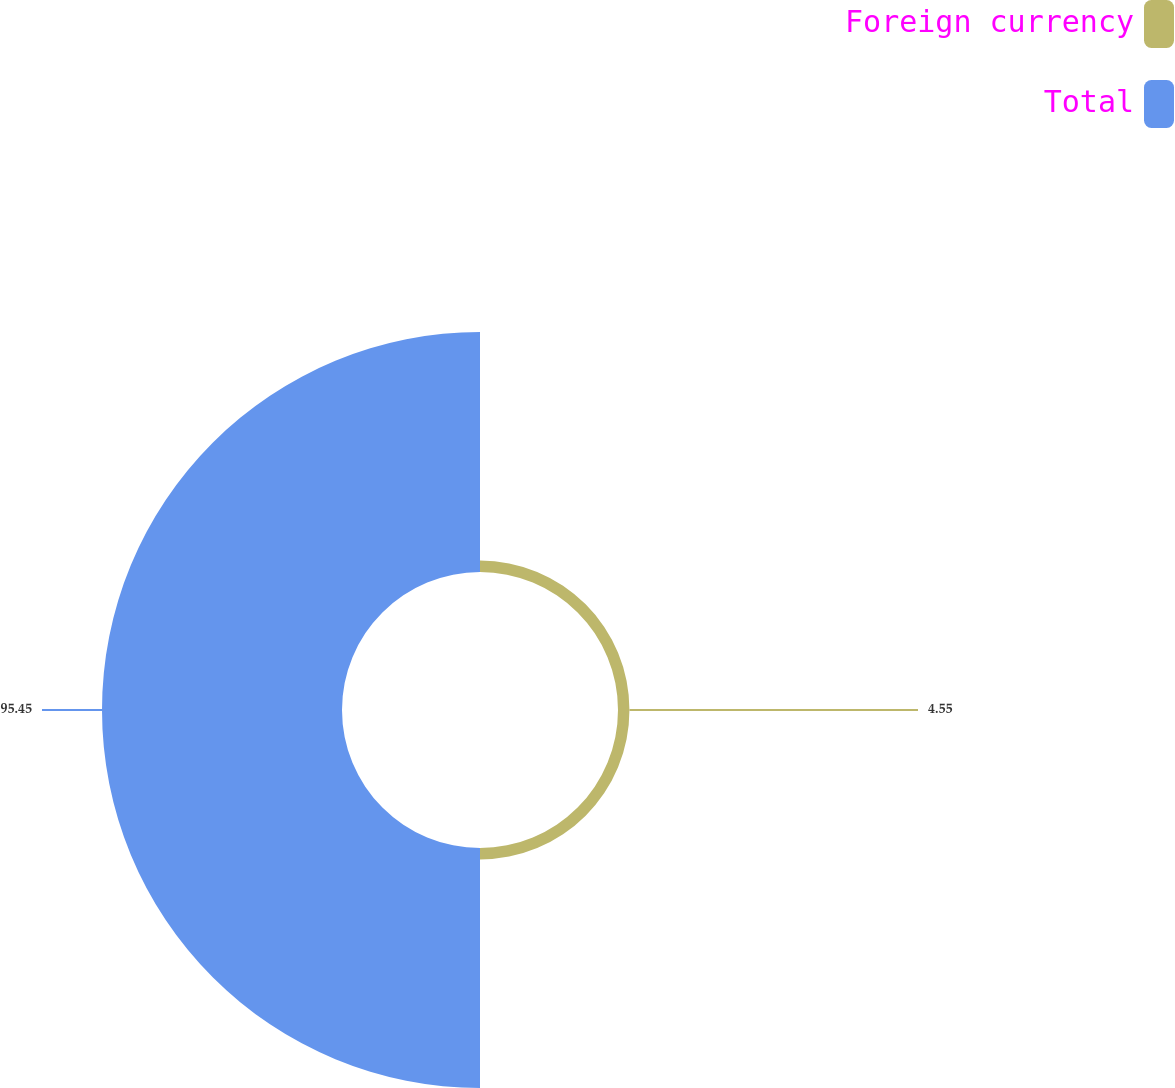Convert chart to OTSL. <chart><loc_0><loc_0><loc_500><loc_500><pie_chart><fcel>Foreign currency<fcel>Total<nl><fcel>4.55%<fcel>95.45%<nl></chart> 